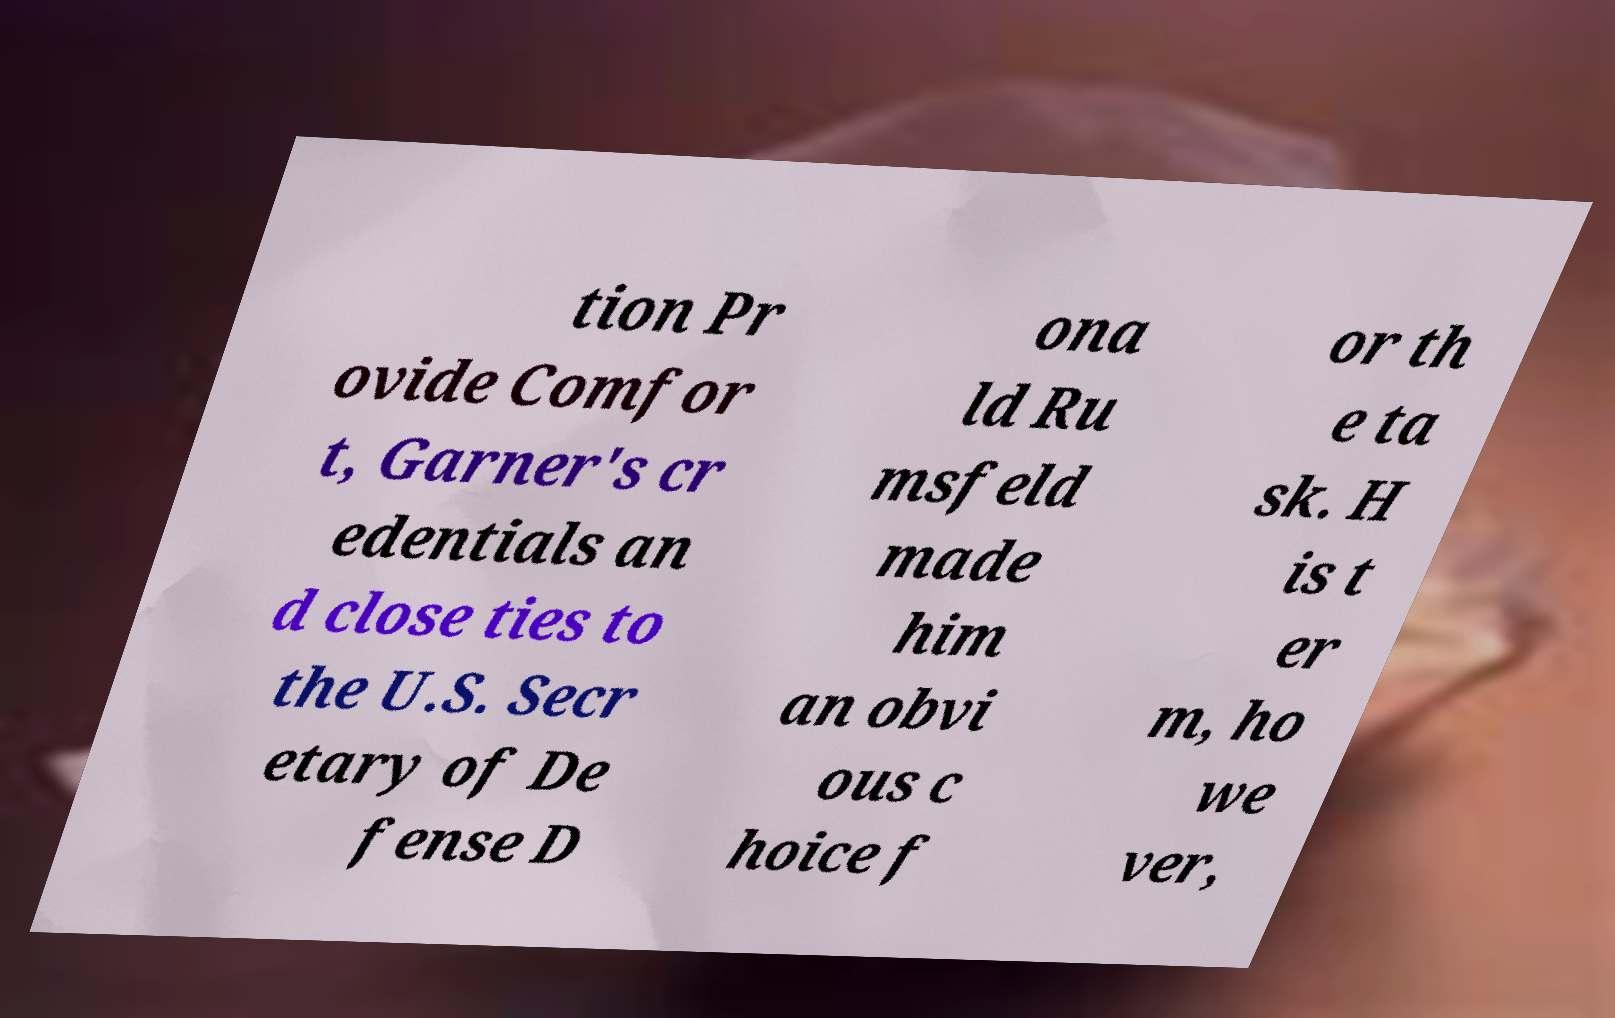I need the written content from this picture converted into text. Can you do that? tion Pr ovide Comfor t, Garner's cr edentials an d close ties to the U.S. Secr etary of De fense D ona ld Ru msfeld made him an obvi ous c hoice f or th e ta sk. H is t er m, ho we ver, 